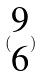<formula> <loc_0><loc_0><loc_500><loc_500>( \begin{matrix} 9 \\ 6 \end{matrix} )</formula> 